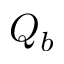<formula> <loc_0><loc_0><loc_500><loc_500>Q _ { b }</formula> 